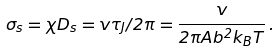<formula> <loc_0><loc_0><loc_500><loc_500>\sigma _ { s } = \chi D _ { s } = v \tau _ { J } / 2 \pi = \frac { \hbar { v } } { 2 \pi A b ^ { 2 } k _ { B } T } \, .</formula> 